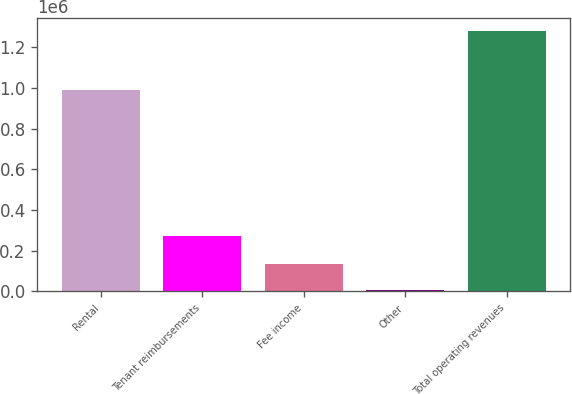Convert chart. <chart><loc_0><loc_0><loc_500><loc_500><bar_chart><fcel>Rental<fcel>Tenant reimbursements<fcel>Fee income<fcel>Other<fcel>Total operating revenues<nl><fcel>990715<fcel>272309<fcel>134760<fcel>7615<fcel>1.27907e+06<nl></chart> 